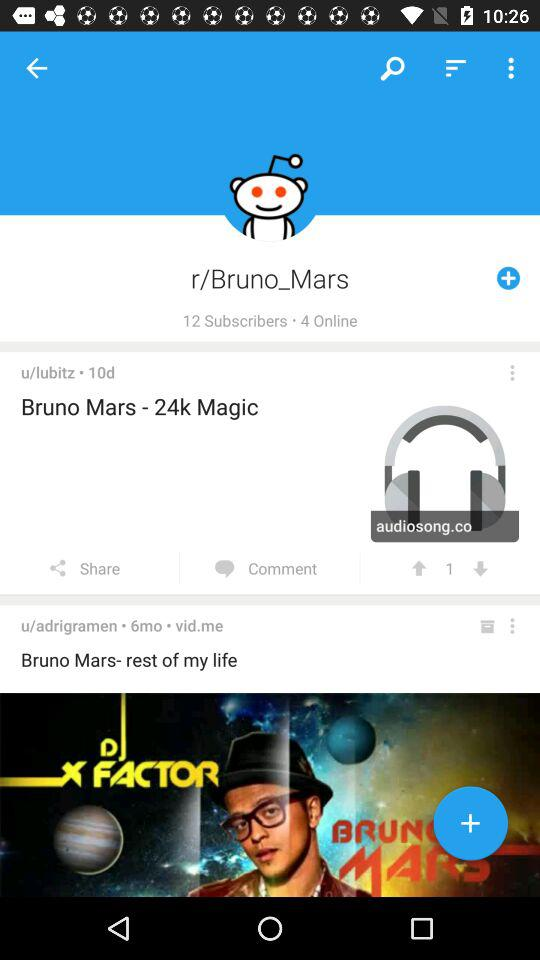How many people are online? There are 4 people online. 